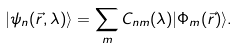<formula> <loc_0><loc_0><loc_500><loc_500>| \psi _ { n } ( \vec { r } , \lambda ) \rangle = \sum _ { m } C _ { n m } ( \lambda ) | \Phi _ { m } ( \vec { r } ) \rangle .</formula> 